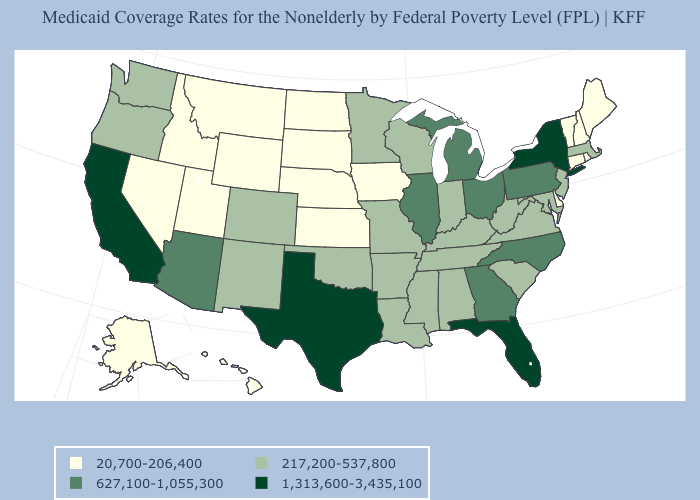What is the value of Alaska?
Concise answer only. 20,700-206,400. How many symbols are there in the legend?
Answer briefly. 4. What is the value of Delaware?
Concise answer only. 20,700-206,400. Does California have the highest value in the West?
Quick response, please. Yes. Does Oregon have the same value as Illinois?
Answer briefly. No. How many symbols are there in the legend?
Answer briefly. 4. Name the states that have a value in the range 627,100-1,055,300?
Write a very short answer. Arizona, Georgia, Illinois, Michigan, North Carolina, Ohio, Pennsylvania. What is the value of Hawaii?
Quick response, please. 20,700-206,400. Does the first symbol in the legend represent the smallest category?
Concise answer only. Yes. What is the value of California?
Quick response, please. 1,313,600-3,435,100. What is the value of Florida?
Give a very brief answer. 1,313,600-3,435,100. Which states have the lowest value in the West?
Be succinct. Alaska, Hawaii, Idaho, Montana, Nevada, Utah, Wyoming. Does the map have missing data?
Give a very brief answer. No. Name the states that have a value in the range 1,313,600-3,435,100?
Quick response, please. California, Florida, New York, Texas. 